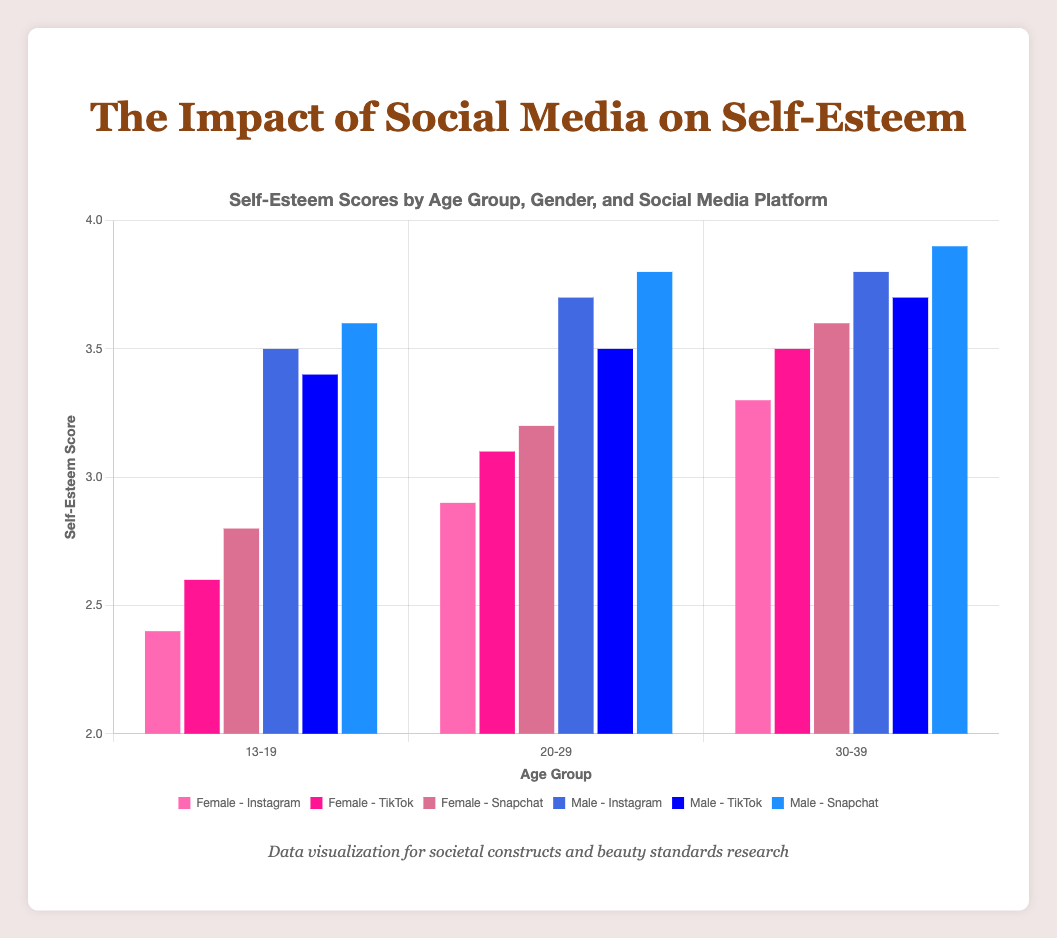What is the average self-esteem score for 13-19-year-old females across all platforms? Look at the self-esteem scores for 13-19-year-old females on Instagram (2.4), TikTok (2.6), and Snapchat (2.8). Sum these values and divide by the number of platforms: (2.4 + 2.6 + 2.8) / 3 = 2.6
Answer: 2.6 Which gender has the higher self-esteem score for the 20-29 age group on Instagram? Look at the self-esteem scores for 20-29-year-olds on Instagram: Females have a score of 2.9, while males have a score of 3.7. Males have the higher score
Answer: Males What's the difference in average daily hours spent on Snapchat between 13-19-year-old males and females? Look at the average daily hours spent on Snapchat: 13-19-year-old females spend 2.1 hours, and 13-19-year-old males spend 1.8 hours. The difference is 2.1 - 1.8 = 0.3 hours
Answer: 0.3 Which platform shows the highest self-esteem score for 30-39-year-old males? Look at the self-esteem scores for 30-39-year-old males: Instagram (3.8), TikTok (3.7), and Snapchat (3.9). The highest score is on Snapchat
Answer: Snapchat What is the median self-esteem score for 20-29-year-old females across all platforms? Look at the self-esteem scores for 20-29-year-old females: Instagram (2.9), TikTok (3.1), and Snapchat (3.2). The median value is the middle value when the scores are sorted (2.9, 3.1, 3.2), so the median is 3.1
Answer: 3.1 